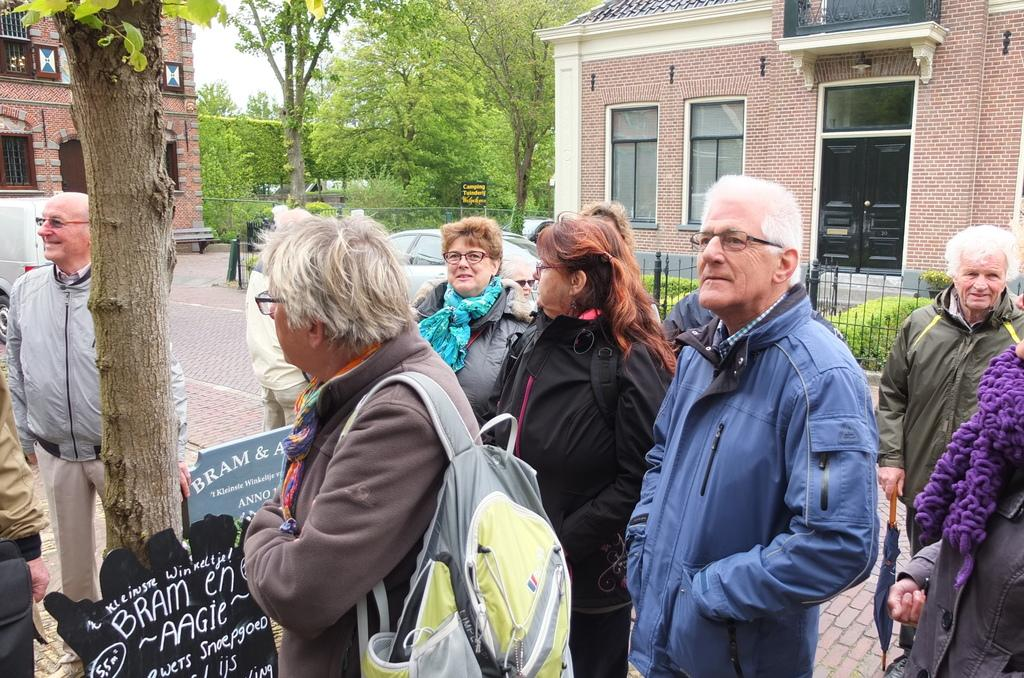What are the people in the image doing? The people in the image are standing in the center. What are the people wearing? The people are wearing jackets. What can be seen in the background of the image? There are trees, houses, and cars in the background of the image. What type of milk is being served to the boys in the image? There are no boys or milk present in the image. 